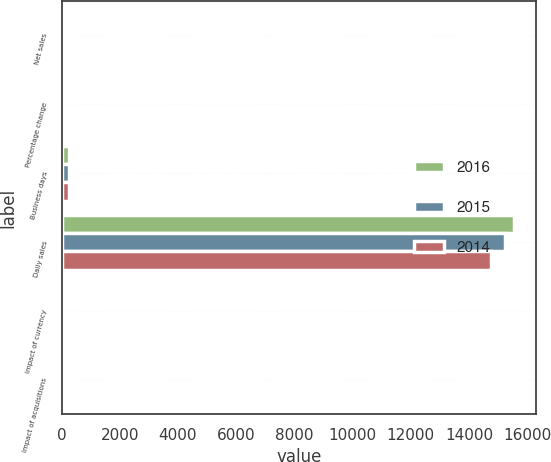Convert chart to OTSL. <chart><loc_0><loc_0><loc_500><loc_500><stacked_bar_chart><ecel><fcel>Net sales<fcel>Percentage change<fcel>Business days<fcel>Daily sales<fcel>Impact of currency<fcel>Impact of acquisitions<nl><fcel>2016<fcel>3.6<fcel>2.4<fcel>255<fcel>15537<fcel>0.4<fcel>0.6<nl><fcel>2015<fcel>3.6<fcel>3.6<fcel>254<fcel>15233<fcel>1.2<fcel>0.2<nl><fcel>2014<fcel>3.6<fcel>12.2<fcel>253<fcel>14757<fcel>0.5<fcel>0.2<nl></chart> 